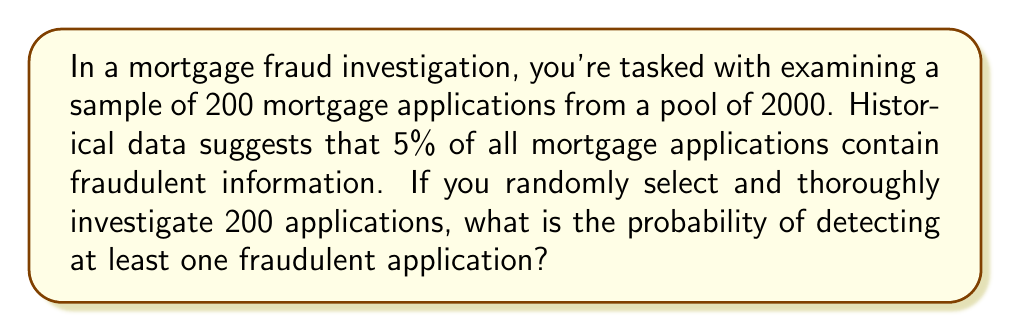Can you solve this math problem? Let's approach this step-by-step:

1) First, we need to calculate the probability of not detecting any fraudulent applications in our sample.

2) The probability of an application being fraudulent is 5% or 0.05.

3) Therefore, the probability of an application being legitimate is 1 - 0.05 = 0.95.

4) For us to not detect any fraud, all 200 selected applications must be legitimate.

5) The probability of this happening is:

   $$(0.95)^{200}$$

6) Now, the probability of detecting at least one fraudulent application is the opposite of not detecting any. So we subtract this probability from 1:

   $$1 - (0.95)^{200}$$

7) Let's calculate this:
   
   $$1 - (0.95)^{200} = 1 - 3.5108 \times 10^{-5} = 0.999964892$$

8) Converting to a percentage:

   $$0.999964892 \times 100\% = 99.9965\%$$
Answer: 99.9965% 